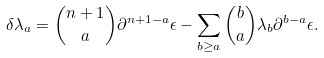Convert formula to latex. <formula><loc_0><loc_0><loc_500><loc_500>\delta \lambda _ { a } = { \binom { n + 1 } { a } } \partial ^ { n + 1 - a } \epsilon - \sum _ { b \geq a } { \binom { b } { a } } \lambda _ { b } \partial ^ { b - a } \epsilon .</formula> 